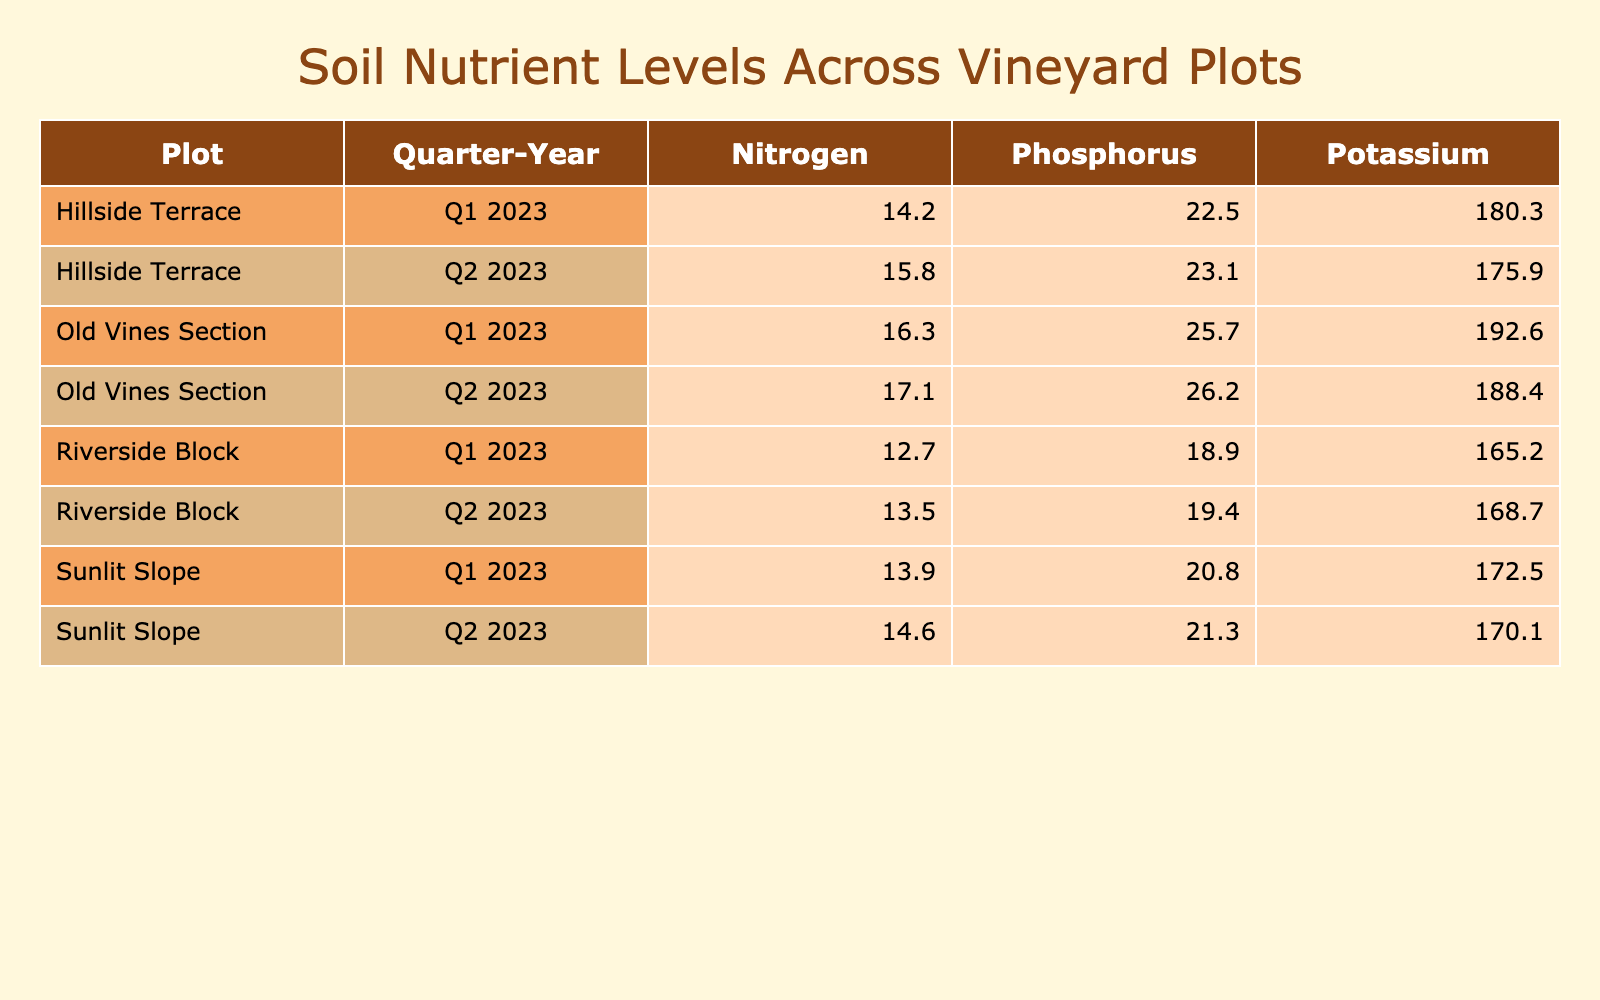What is the nitrogen level for the Old Vines Section in Q1 2023? In the table, I locate the row for Old Vines Section in Q1 2023 under the Nitrogen column, which indicates a level of 16.3.
Answer: 16.3 Which plot had the highest potassium level in Q2 2023? Looking at the Q2 2023 data in the Potassium column, I see Old Vines Section has a level of 188.4, which is the highest compared to other plots.
Answer: Old Vines Section What was the phosphorus level for the Riverside Block in Q1 2023? By finding the Riverside Block in Q1 2023 within the Phosphorus column, the level recorded is 18.9.
Answer: 18.9 What are the nitrogen levels across all plots in Q2 2023? I check the nitrogen levels for each plot in Q2 2023: Hillside Terrace is 15.8, Riverside Block is 13.5, Old Vines Section is 17.1, and Sunlit Slope is 14.6. The response includes all those levels.
Answer: 15.8, 13.5, 17.1, 14.6 Is the potassium level in Hillside Terrace higher or lower compared to Old Vines Section in Q1 2023? In Q1 2023, Hillside Terrace has a potassium level of 180.3, while Old Vines Section has 192.6. Since 180.3 is lower than 192.6, the answer is "lower."
Answer: Lower What is the average nitrogen level across all plots in Q1 2023? The nitrogen levels for Q1 2023 are: Hillside Terrace 14.2, Riverside Block 12.7, Old Vines Section 16.3, and Sunlit Slope 13.9. Adding these gives 14.2 + 12.7 + 16.3 + 13.9 = 57.1. Dividing by 4 for the average gives 57.1 / 4 = 14.275.
Answer: 14.275 Which plot had the lowest phosphorus level in Q2 2023? I look at the phosphorus levels for Q2 2023: Hillside Terrace is 23.1, Riverside Block is 19.4, Old Vines Section is 26.2, and Sunlit Slope is 21.3. Riverside Block at 19.4 is the lowest.
Answer: Riverside Block What is the difference in potassium levels between Hillside Terrace and Sunlit Slope in Q1 2023? Hillside Terrace has a potassium level of 180.3 and Sunlit Slope has 172.5. The difference is calculated as 180.3 - 172.5 = 7.8.
Answer: 7.8 How many times greater is the phosphorus level in Old Vines Section Q2 2023 than in Riverside Block Q1 2023? Old Vines Section in Q2 2023 has a phosphorus level of 26.2, while Riverside Block in Q1 2023 has 18.9. To find how many times greater, I divide: 26.2 / 18.9 ≈ 1.39.
Answer: Approximately 1.39 Which nutrient has the highest concentration in Sunlit Slope for Q1 2023? In Sunlit Slope Q1 2023, the nitrogen level is 13.9, phosphorus is 20.8, and potassium is 172.5. Comparing these, potassium at 172.5 is the highest.
Answer: Potassium Are the nitrogen levels in Q1 2023 higher than those in Q2 2023 for all plots? For each plot, I compare the nitrogen levels: Hillside Terrace, Q1 is 14.2 vs Q2 15.8 (Q2 is higher); Riverside Block, Q1 is 12.7 vs Q2 13.5 (Q2 is higher); Old Vines Section, Q1 is 16.3 vs Q2 17.1 (Q2 is higher); Sunlit Slope, Q1 is 13.9 vs Q2 14.6 (Q2 is higher). Therefore, the answer is "No."
Answer: No 